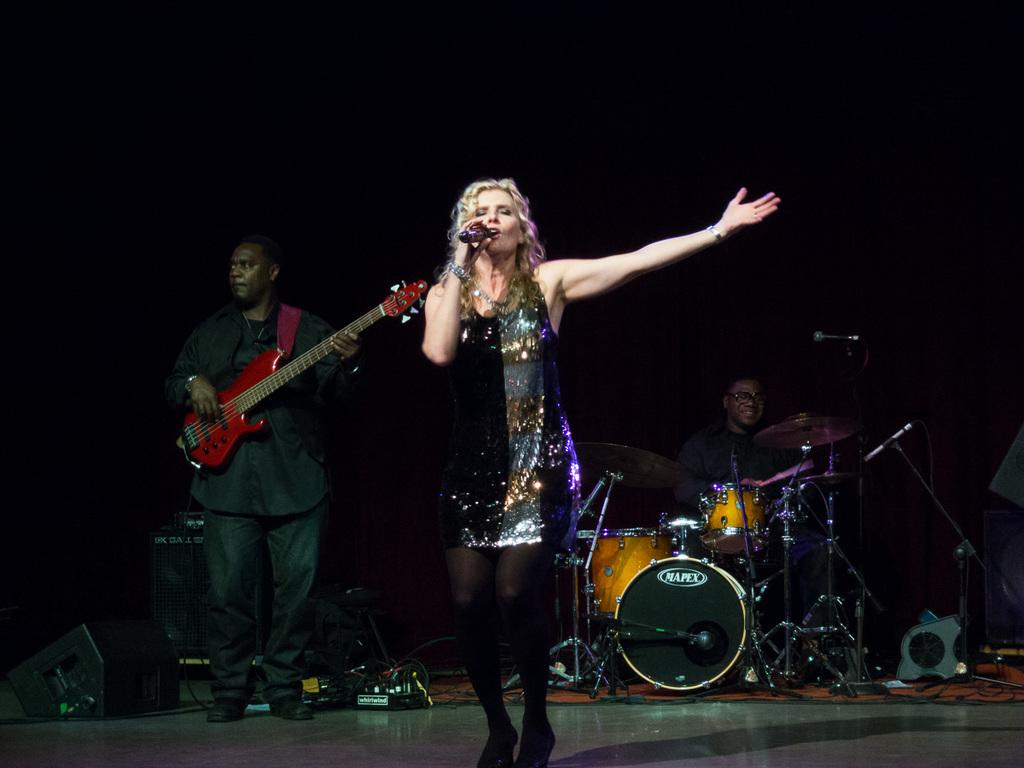What is the woman in the image doing? The woman is singing on a microphone. What is the surface beneath the woman and the man in the image? There is a floor in the image. What other objects are present in the image related to music? There are musical instruments in the image. What is the man in the image doing? The man is playing a guitar. Can you see any hills in the image? There are no hills visible in the image. Is there a quill being used by the woman while she sings? There is no quill present in the image; the woman is using a microphone to sing. 